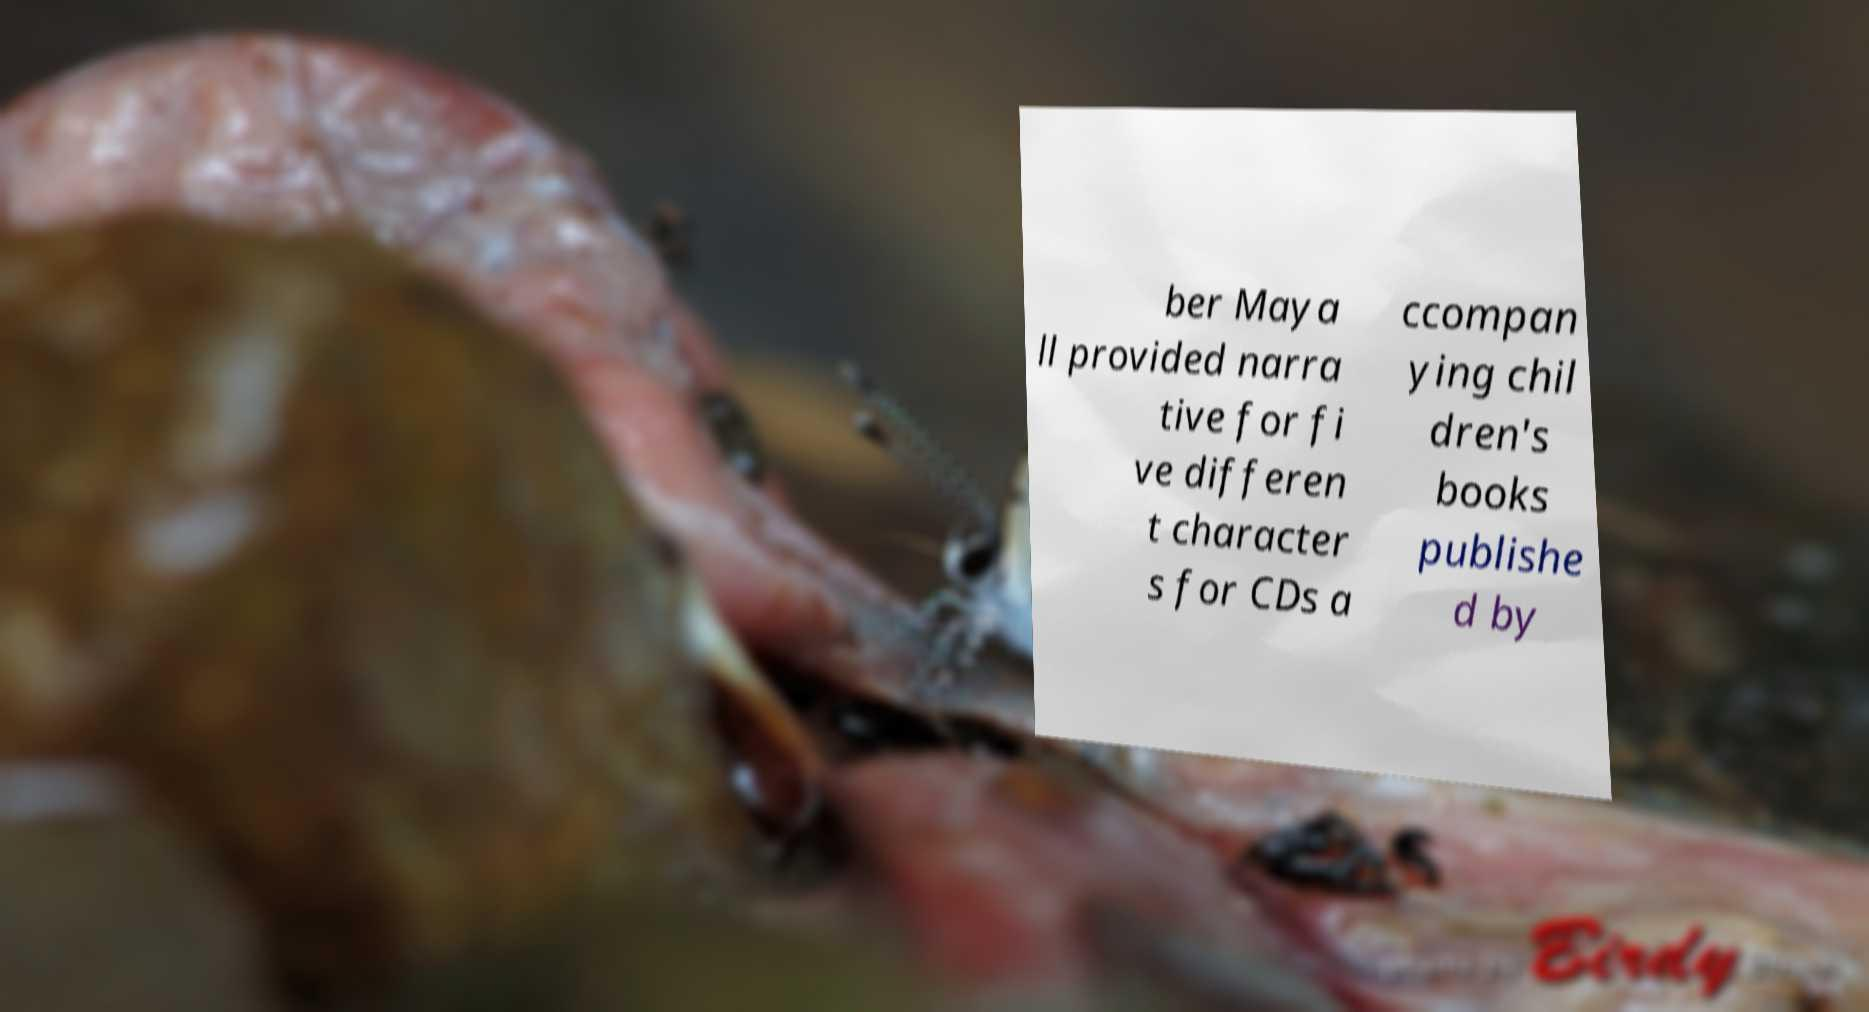Please identify and transcribe the text found in this image. ber Maya ll provided narra tive for fi ve differen t character s for CDs a ccompan ying chil dren's books publishe d by 